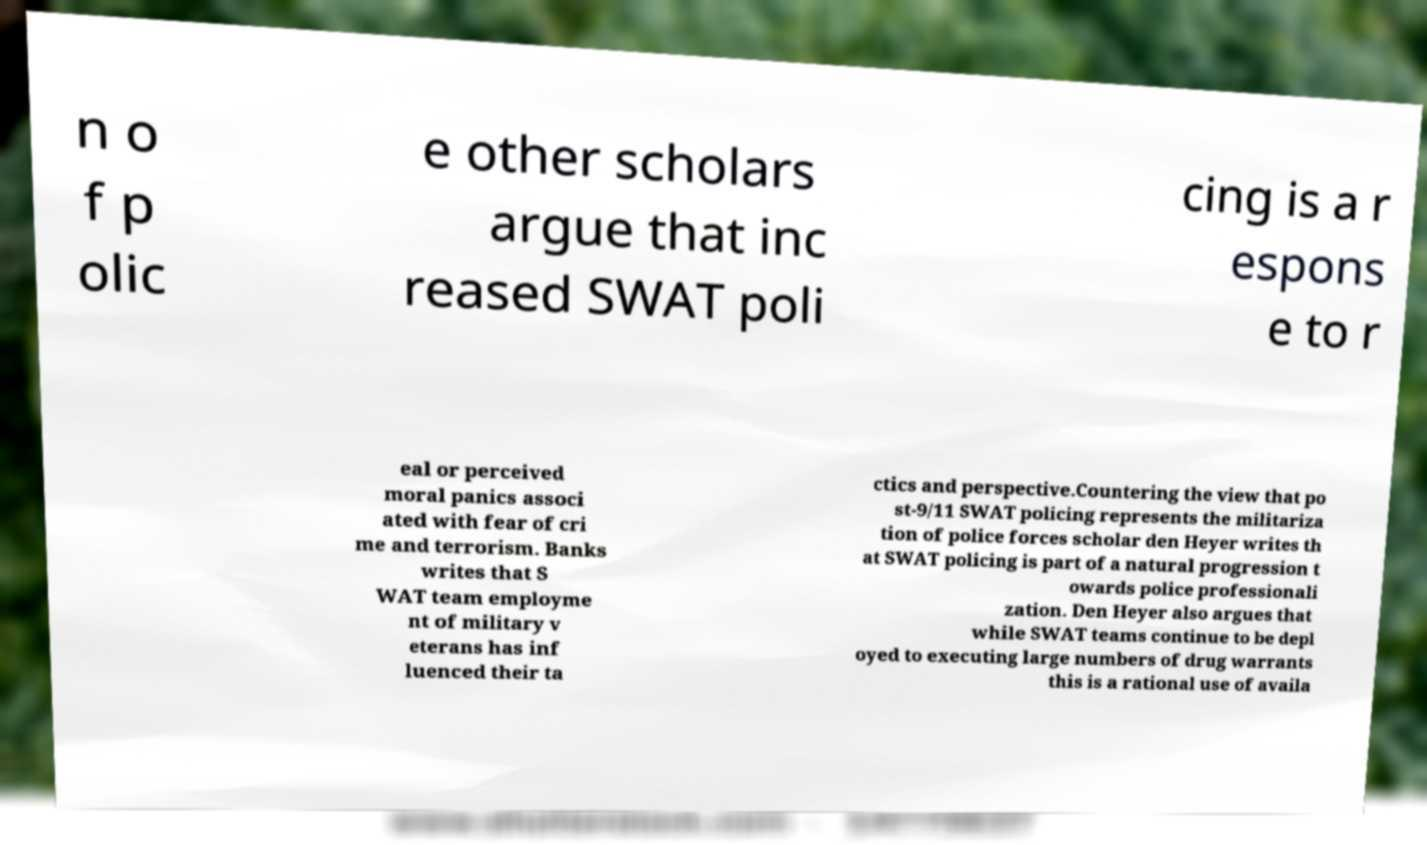Please read and relay the text visible in this image. What does it say? n o f p olic e other scholars argue that inc reased SWAT poli cing is a r espons e to r eal or perceived moral panics associ ated with fear of cri me and terrorism. Banks writes that S WAT team employme nt of military v eterans has inf luenced their ta ctics and perspective.Countering the view that po st-9/11 SWAT policing represents the militariza tion of police forces scholar den Heyer writes th at SWAT policing is part of a natural progression t owards police professionali zation. Den Heyer also argues that while SWAT teams continue to be depl oyed to executing large numbers of drug warrants this is a rational use of availa 